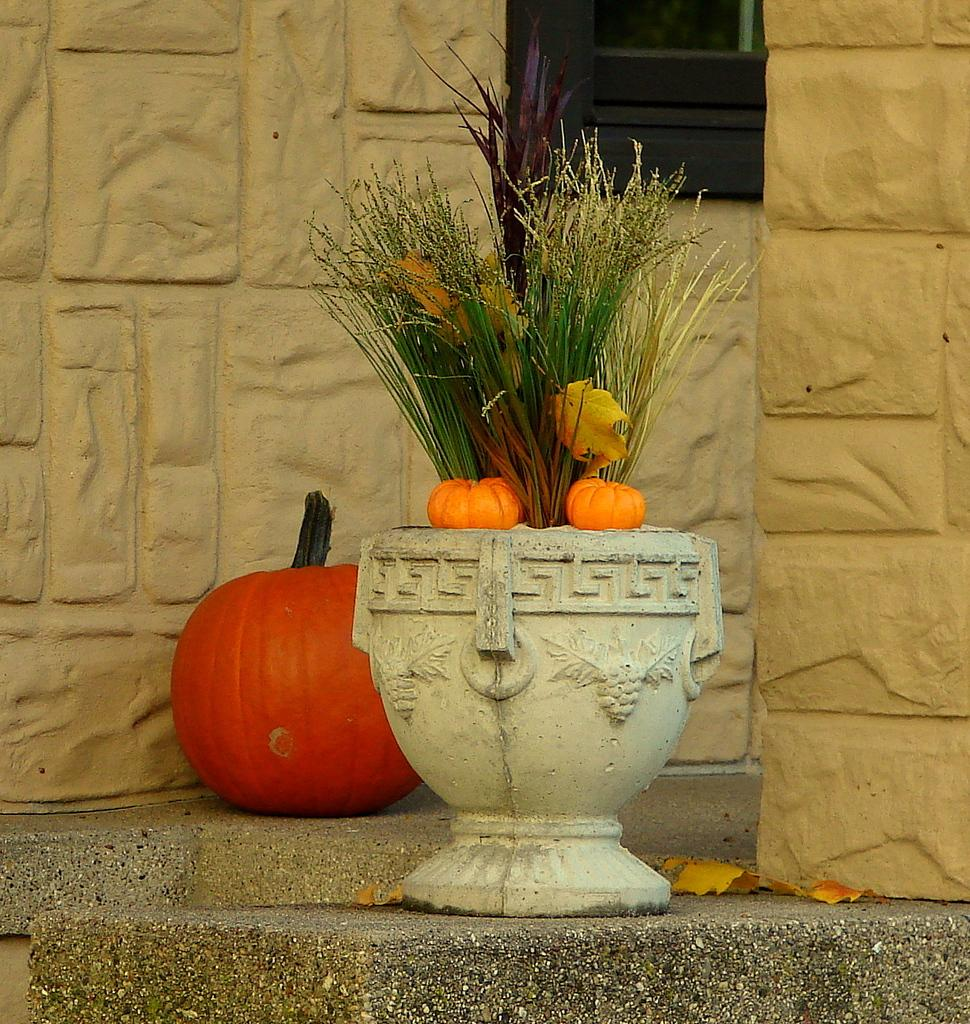What is the main object in the center of the image? There is a pot in the center of the image. What is associated with the pot in the image? There are pumpkins in or around the pot. What can be seen in the background of the image? There is a wall in the background of the image. What type of current can be seen flowing through the pumpkins in the image? There is no current flowing through the pumpkins in the image; they are not electrical components. 